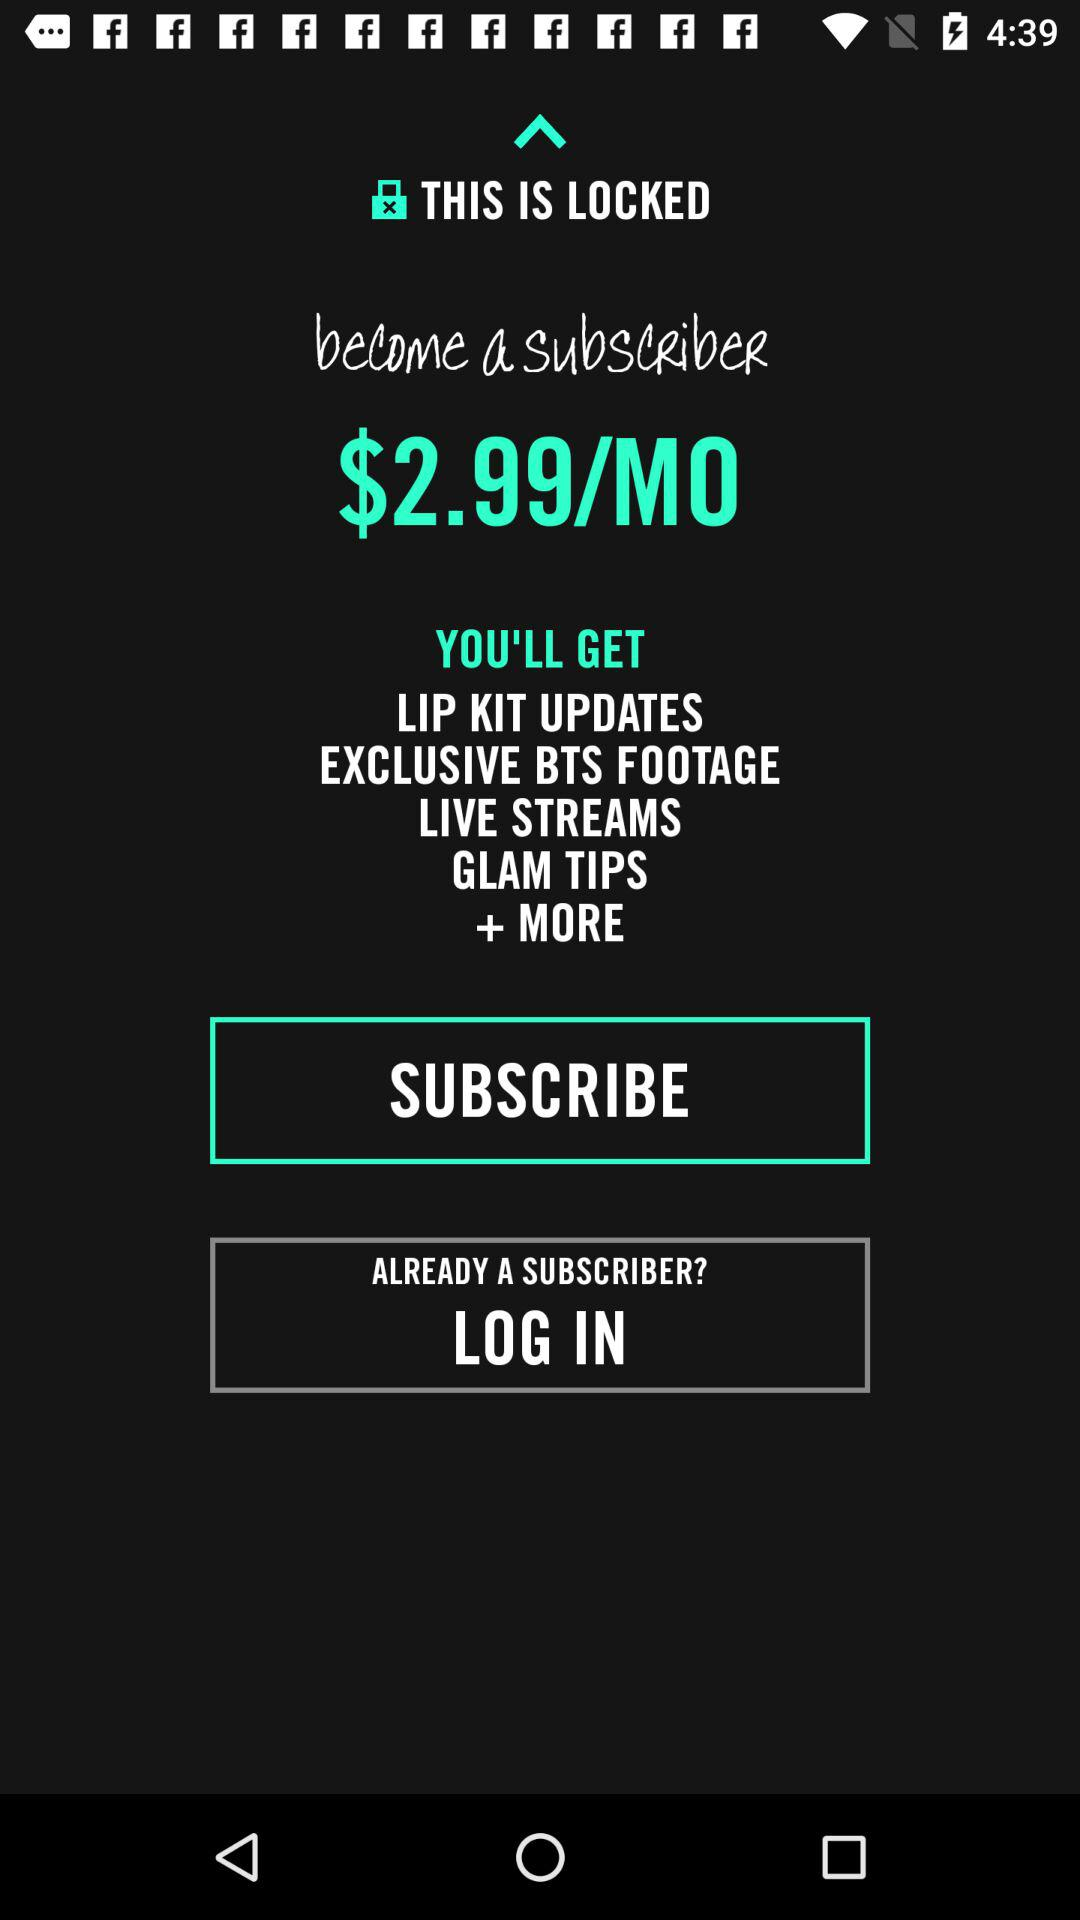What is the cost of a subscription for one month? The subscription cost for one month is $2.99. 